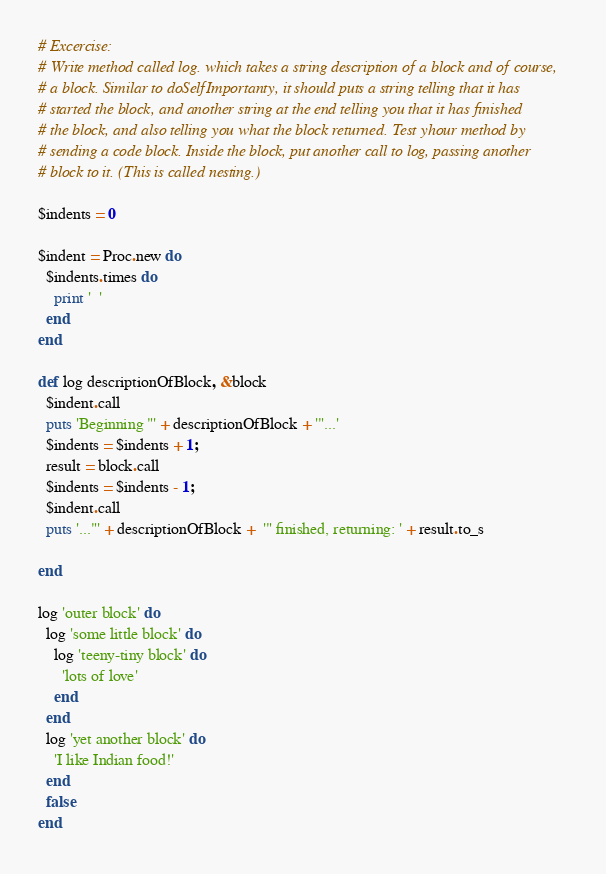<code> <loc_0><loc_0><loc_500><loc_500><_Ruby_># Excercise:
# Write method called log. which takes a string description of a block and of course,
# a block. Similar to doSelfImportanty, it should puts a string telling that it has 
# started the block, and another string at the end telling you that it has finished
# the block, and also telling you what the block returned. Test yhour method by 
# sending a code block. Inside the block, put another call to log, passing another 
# block to it. (This is called nesting.) 

$indents = 0

$indent = Proc.new do
  $indents.times do
    print '  '
  end
end

def log descriptionOfBlock, &block
  $indent.call
  puts 'Beginning "' + descriptionOfBlock + '"...'
  $indents = $indents + 1;
  result = block.call
  $indents = $indents - 1;
  $indent.call
  puts '..."' + descriptionOfBlock +  '" finished, returning: ' + result.to_s
  
end

log 'outer block' do
  log 'some little block' do 
    log 'teeny-tiny block' do
      'lots of love'
    end
  end
  log 'yet another block' do
    'I like Indian food!'
  end
  false
end

</code> 